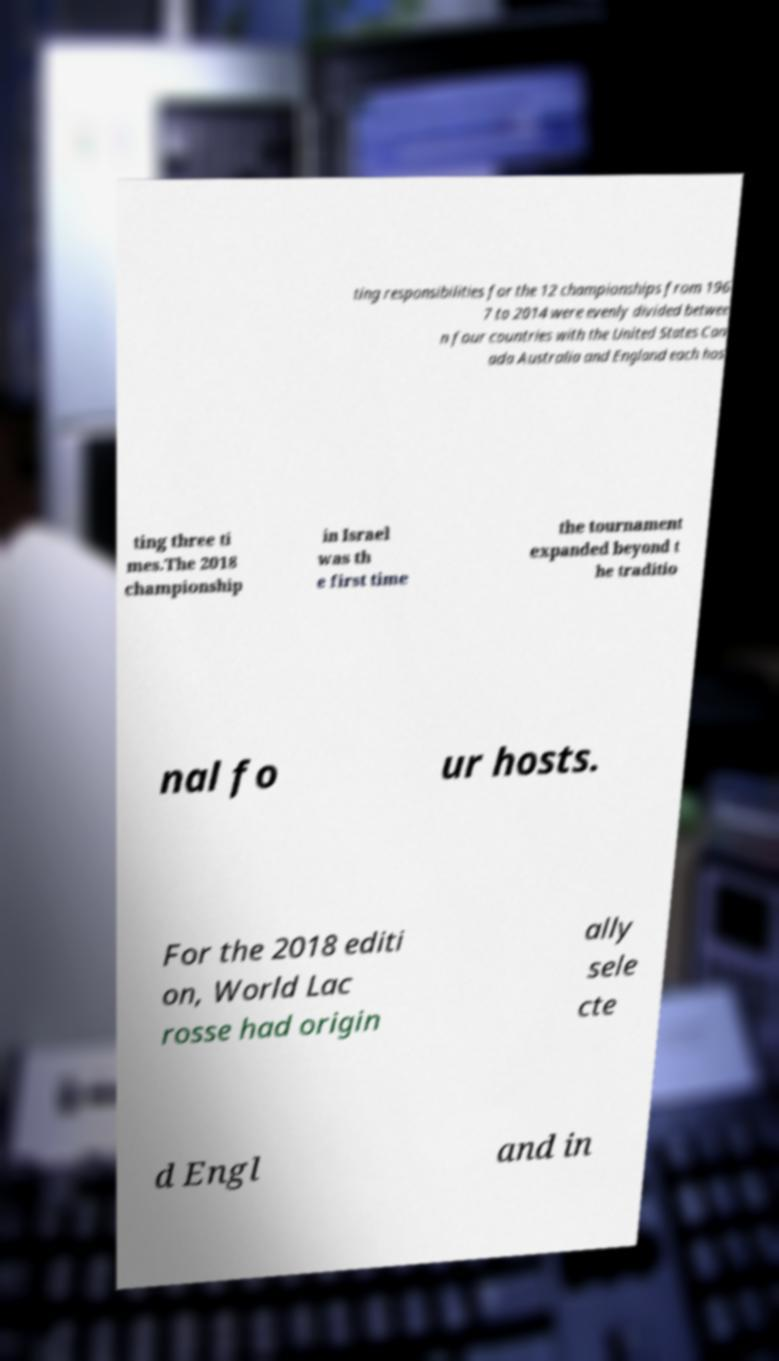Please identify and transcribe the text found in this image. ting responsibilities for the 12 championships from 196 7 to 2014 were evenly divided betwee n four countries with the United States Can ada Australia and England each hos ting three ti mes.The 2018 championship in Israel was th e first time the tournament expanded beyond t he traditio nal fo ur hosts. For the 2018 editi on, World Lac rosse had origin ally sele cte d Engl and in 